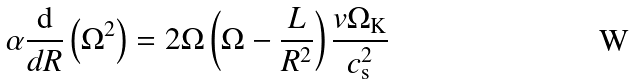Convert formula to latex. <formula><loc_0><loc_0><loc_500><loc_500>\alpha \frac { \mathrm d } { d R } \left ( \Omega ^ { 2 } \right ) = 2 \Omega \left ( \Omega - \frac { L } { R ^ { 2 } } \right ) \frac { v \Omega _ { \mathrm K } } { c _ { \mathrm s } ^ { 2 } }</formula> 